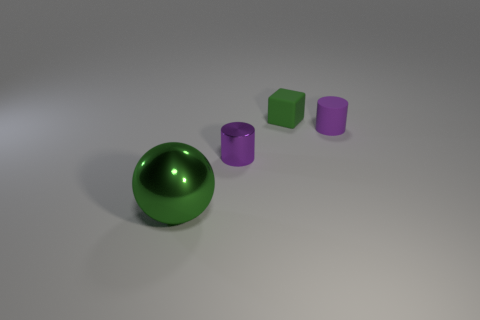Add 4 tiny purple shiny objects. How many objects exist? 8 Subtract all spheres. How many objects are left? 3 Add 1 gray metal objects. How many gray metal objects exist? 1 Subtract 0 blue cylinders. How many objects are left? 4 Subtract all purple matte things. Subtract all tiny green things. How many objects are left? 2 Add 2 small green things. How many small green things are left? 3 